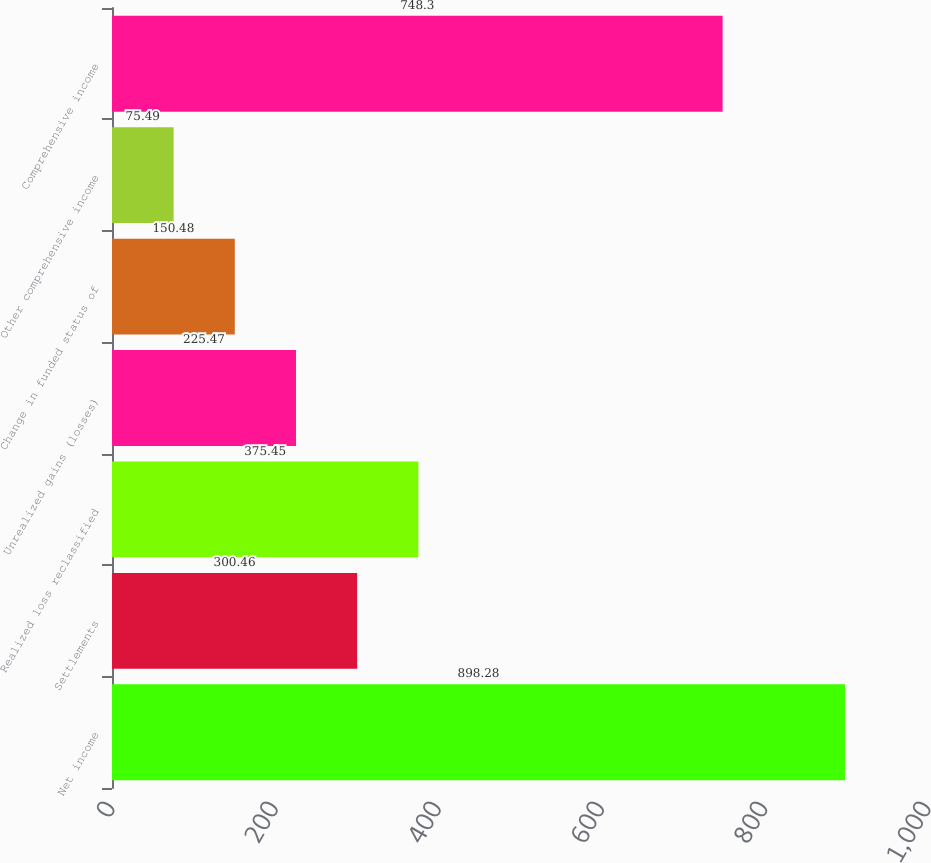Convert chart to OTSL. <chart><loc_0><loc_0><loc_500><loc_500><bar_chart><fcel>Net income<fcel>Settlements<fcel>Realized loss reclassified<fcel>Unrealized gains (losses)<fcel>Change in funded status of<fcel>Other comprehensive income<fcel>Comprehensive income<nl><fcel>898.28<fcel>300.46<fcel>375.45<fcel>225.47<fcel>150.48<fcel>75.49<fcel>748.3<nl></chart> 